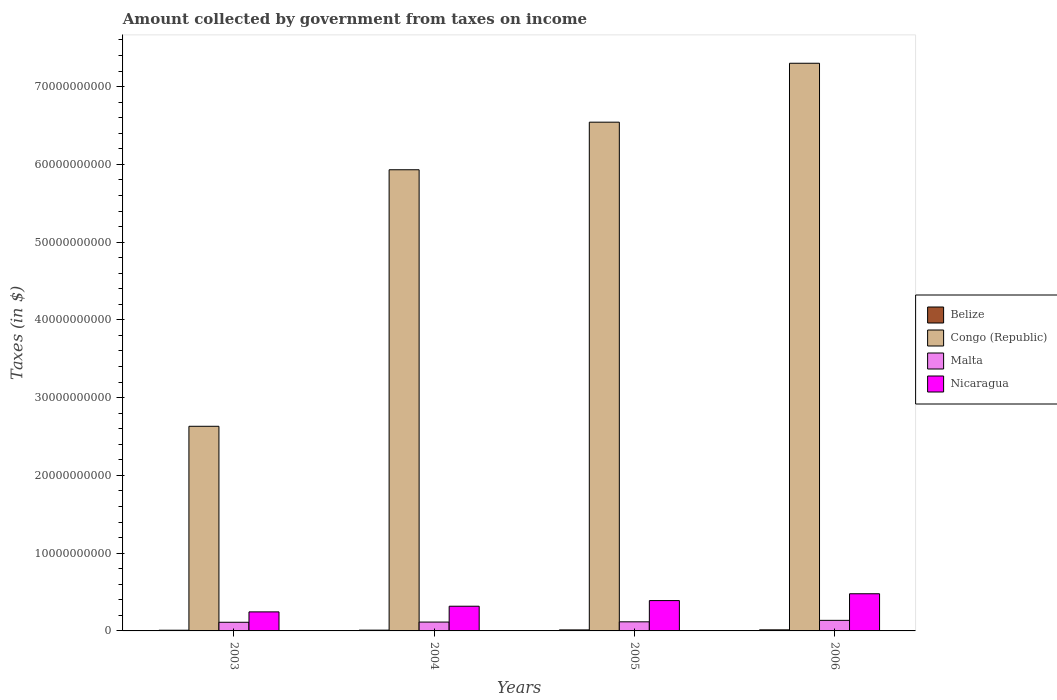Are the number of bars per tick equal to the number of legend labels?
Keep it short and to the point. Yes. Are the number of bars on each tick of the X-axis equal?
Keep it short and to the point. Yes. How many bars are there on the 3rd tick from the left?
Your response must be concise. 4. How many bars are there on the 4th tick from the right?
Your answer should be compact. 4. What is the label of the 1st group of bars from the left?
Provide a succinct answer. 2003. In how many cases, is the number of bars for a given year not equal to the number of legend labels?
Provide a short and direct response. 0. What is the amount collected by government from taxes on income in Nicaragua in 2004?
Ensure brevity in your answer.  3.18e+09. Across all years, what is the maximum amount collected by government from taxes on income in Congo (Republic)?
Provide a short and direct response. 7.30e+1. Across all years, what is the minimum amount collected by government from taxes on income in Malta?
Keep it short and to the point. 1.11e+09. In which year was the amount collected by government from taxes on income in Nicaragua minimum?
Give a very brief answer. 2003. What is the total amount collected by government from taxes on income in Congo (Republic) in the graph?
Offer a terse response. 2.24e+11. What is the difference between the amount collected by government from taxes on income in Nicaragua in 2003 and that in 2004?
Keep it short and to the point. -7.28e+08. What is the difference between the amount collected by government from taxes on income in Belize in 2003 and the amount collected by government from taxes on income in Malta in 2006?
Ensure brevity in your answer.  -1.27e+09. What is the average amount collected by government from taxes on income in Belize per year?
Your answer should be very brief. 1.14e+08. In the year 2005, what is the difference between the amount collected by government from taxes on income in Malta and amount collected by government from taxes on income in Nicaragua?
Provide a succinct answer. -2.73e+09. What is the ratio of the amount collected by government from taxes on income in Malta in 2003 to that in 2005?
Your answer should be compact. 0.95. Is the amount collected by government from taxes on income in Congo (Republic) in 2004 less than that in 2005?
Make the answer very short. Yes. What is the difference between the highest and the second highest amount collected by government from taxes on income in Nicaragua?
Keep it short and to the point. 8.78e+08. What is the difference between the highest and the lowest amount collected by government from taxes on income in Nicaragua?
Keep it short and to the point. 2.33e+09. Is the sum of the amount collected by government from taxes on income in Malta in 2005 and 2006 greater than the maximum amount collected by government from taxes on income in Nicaragua across all years?
Make the answer very short. No. What does the 4th bar from the left in 2004 represents?
Your answer should be compact. Nicaragua. What does the 4th bar from the right in 2005 represents?
Offer a terse response. Belize. Is it the case that in every year, the sum of the amount collected by government from taxes on income in Nicaragua and amount collected by government from taxes on income in Congo (Republic) is greater than the amount collected by government from taxes on income in Malta?
Provide a short and direct response. Yes. How many years are there in the graph?
Keep it short and to the point. 4. What is the difference between two consecutive major ticks on the Y-axis?
Your answer should be very brief. 1.00e+1. Where does the legend appear in the graph?
Your answer should be very brief. Center right. How many legend labels are there?
Your answer should be compact. 4. How are the legend labels stacked?
Provide a short and direct response. Vertical. What is the title of the graph?
Provide a succinct answer. Amount collected by government from taxes on income. Does "Saudi Arabia" appear as one of the legend labels in the graph?
Provide a succinct answer. No. What is the label or title of the Y-axis?
Give a very brief answer. Taxes (in $). What is the Taxes (in $) of Belize in 2003?
Your answer should be compact. 8.91e+07. What is the Taxes (in $) in Congo (Republic) in 2003?
Offer a very short reply. 2.63e+1. What is the Taxes (in $) in Malta in 2003?
Provide a short and direct response. 1.11e+09. What is the Taxes (in $) in Nicaragua in 2003?
Offer a terse response. 2.45e+09. What is the Taxes (in $) of Belize in 2004?
Provide a succinct answer. 9.98e+07. What is the Taxes (in $) in Congo (Republic) in 2004?
Provide a short and direct response. 5.93e+1. What is the Taxes (in $) in Malta in 2004?
Your answer should be compact. 1.14e+09. What is the Taxes (in $) of Nicaragua in 2004?
Give a very brief answer. 3.18e+09. What is the Taxes (in $) of Belize in 2005?
Keep it short and to the point. 1.29e+08. What is the Taxes (in $) in Congo (Republic) in 2005?
Ensure brevity in your answer.  6.54e+1. What is the Taxes (in $) of Malta in 2005?
Give a very brief answer. 1.17e+09. What is the Taxes (in $) in Nicaragua in 2005?
Your answer should be compact. 3.90e+09. What is the Taxes (in $) in Belize in 2006?
Provide a succinct answer. 1.38e+08. What is the Taxes (in $) in Congo (Republic) in 2006?
Provide a succinct answer. 7.30e+1. What is the Taxes (in $) in Malta in 2006?
Make the answer very short. 1.36e+09. What is the Taxes (in $) in Nicaragua in 2006?
Make the answer very short. 4.78e+09. Across all years, what is the maximum Taxes (in $) of Belize?
Give a very brief answer. 1.38e+08. Across all years, what is the maximum Taxes (in $) in Congo (Republic)?
Offer a terse response. 7.30e+1. Across all years, what is the maximum Taxes (in $) in Malta?
Make the answer very short. 1.36e+09. Across all years, what is the maximum Taxes (in $) in Nicaragua?
Your response must be concise. 4.78e+09. Across all years, what is the minimum Taxes (in $) in Belize?
Your answer should be compact. 8.91e+07. Across all years, what is the minimum Taxes (in $) of Congo (Republic)?
Provide a succinct answer. 2.63e+1. Across all years, what is the minimum Taxes (in $) of Malta?
Your answer should be very brief. 1.11e+09. Across all years, what is the minimum Taxes (in $) of Nicaragua?
Keep it short and to the point. 2.45e+09. What is the total Taxes (in $) of Belize in the graph?
Your answer should be very brief. 4.57e+08. What is the total Taxes (in $) of Congo (Republic) in the graph?
Offer a very short reply. 2.24e+11. What is the total Taxes (in $) in Malta in the graph?
Offer a terse response. 4.78e+09. What is the total Taxes (in $) of Nicaragua in the graph?
Provide a short and direct response. 1.43e+1. What is the difference between the Taxes (in $) in Belize in 2003 and that in 2004?
Ensure brevity in your answer.  -1.07e+07. What is the difference between the Taxes (in $) of Congo (Republic) in 2003 and that in 2004?
Give a very brief answer. -3.30e+1. What is the difference between the Taxes (in $) in Malta in 2003 and that in 2004?
Your answer should be very brief. -2.56e+07. What is the difference between the Taxes (in $) in Nicaragua in 2003 and that in 2004?
Your response must be concise. -7.28e+08. What is the difference between the Taxes (in $) of Belize in 2003 and that in 2005?
Keep it short and to the point. -4.03e+07. What is the difference between the Taxes (in $) of Congo (Republic) in 2003 and that in 2005?
Offer a very short reply. -3.91e+1. What is the difference between the Taxes (in $) in Malta in 2003 and that in 2005?
Ensure brevity in your answer.  -5.76e+07. What is the difference between the Taxes (in $) of Nicaragua in 2003 and that in 2005?
Give a very brief answer. -1.45e+09. What is the difference between the Taxes (in $) in Belize in 2003 and that in 2006?
Your response must be concise. -4.91e+07. What is the difference between the Taxes (in $) of Congo (Republic) in 2003 and that in 2006?
Make the answer very short. -4.67e+1. What is the difference between the Taxes (in $) in Malta in 2003 and that in 2006?
Provide a short and direct response. -2.47e+08. What is the difference between the Taxes (in $) in Nicaragua in 2003 and that in 2006?
Your response must be concise. -2.33e+09. What is the difference between the Taxes (in $) in Belize in 2004 and that in 2005?
Provide a succinct answer. -2.96e+07. What is the difference between the Taxes (in $) of Congo (Republic) in 2004 and that in 2005?
Your response must be concise. -6.12e+09. What is the difference between the Taxes (in $) in Malta in 2004 and that in 2005?
Provide a short and direct response. -3.20e+07. What is the difference between the Taxes (in $) of Nicaragua in 2004 and that in 2005?
Your answer should be very brief. -7.26e+08. What is the difference between the Taxes (in $) of Belize in 2004 and that in 2006?
Your answer should be very brief. -3.84e+07. What is the difference between the Taxes (in $) in Congo (Republic) in 2004 and that in 2006?
Make the answer very short. -1.37e+1. What is the difference between the Taxes (in $) in Malta in 2004 and that in 2006?
Make the answer very short. -2.22e+08. What is the difference between the Taxes (in $) of Nicaragua in 2004 and that in 2006?
Your response must be concise. -1.60e+09. What is the difference between the Taxes (in $) in Belize in 2005 and that in 2006?
Provide a short and direct response. -8.74e+06. What is the difference between the Taxes (in $) in Congo (Republic) in 2005 and that in 2006?
Offer a terse response. -7.58e+09. What is the difference between the Taxes (in $) in Malta in 2005 and that in 2006?
Make the answer very short. -1.90e+08. What is the difference between the Taxes (in $) of Nicaragua in 2005 and that in 2006?
Give a very brief answer. -8.78e+08. What is the difference between the Taxes (in $) in Belize in 2003 and the Taxes (in $) in Congo (Republic) in 2004?
Ensure brevity in your answer.  -5.92e+1. What is the difference between the Taxes (in $) of Belize in 2003 and the Taxes (in $) of Malta in 2004?
Your answer should be compact. -1.05e+09. What is the difference between the Taxes (in $) of Belize in 2003 and the Taxes (in $) of Nicaragua in 2004?
Your response must be concise. -3.09e+09. What is the difference between the Taxes (in $) of Congo (Republic) in 2003 and the Taxes (in $) of Malta in 2004?
Offer a very short reply. 2.52e+1. What is the difference between the Taxes (in $) of Congo (Republic) in 2003 and the Taxes (in $) of Nicaragua in 2004?
Provide a succinct answer. 2.31e+1. What is the difference between the Taxes (in $) of Malta in 2003 and the Taxes (in $) of Nicaragua in 2004?
Your answer should be compact. -2.06e+09. What is the difference between the Taxes (in $) of Belize in 2003 and the Taxes (in $) of Congo (Republic) in 2005?
Provide a succinct answer. -6.53e+1. What is the difference between the Taxes (in $) of Belize in 2003 and the Taxes (in $) of Malta in 2005?
Offer a very short reply. -1.08e+09. What is the difference between the Taxes (in $) of Belize in 2003 and the Taxes (in $) of Nicaragua in 2005?
Your answer should be compact. -3.81e+09. What is the difference between the Taxes (in $) in Congo (Republic) in 2003 and the Taxes (in $) in Malta in 2005?
Offer a very short reply. 2.51e+1. What is the difference between the Taxes (in $) in Congo (Republic) in 2003 and the Taxes (in $) in Nicaragua in 2005?
Offer a very short reply. 2.24e+1. What is the difference between the Taxes (in $) in Malta in 2003 and the Taxes (in $) in Nicaragua in 2005?
Give a very brief answer. -2.79e+09. What is the difference between the Taxes (in $) in Belize in 2003 and the Taxes (in $) in Congo (Republic) in 2006?
Your answer should be compact. -7.29e+1. What is the difference between the Taxes (in $) in Belize in 2003 and the Taxes (in $) in Malta in 2006?
Keep it short and to the point. -1.27e+09. What is the difference between the Taxes (in $) in Belize in 2003 and the Taxes (in $) in Nicaragua in 2006?
Ensure brevity in your answer.  -4.69e+09. What is the difference between the Taxes (in $) of Congo (Republic) in 2003 and the Taxes (in $) of Malta in 2006?
Ensure brevity in your answer.  2.50e+1. What is the difference between the Taxes (in $) of Congo (Republic) in 2003 and the Taxes (in $) of Nicaragua in 2006?
Make the answer very short. 2.15e+1. What is the difference between the Taxes (in $) in Malta in 2003 and the Taxes (in $) in Nicaragua in 2006?
Make the answer very short. -3.67e+09. What is the difference between the Taxes (in $) in Belize in 2004 and the Taxes (in $) in Congo (Republic) in 2005?
Offer a very short reply. -6.53e+1. What is the difference between the Taxes (in $) of Belize in 2004 and the Taxes (in $) of Malta in 2005?
Offer a very short reply. -1.07e+09. What is the difference between the Taxes (in $) of Belize in 2004 and the Taxes (in $) of Nicaragua in 2005?
Give a very brief answer. -3.80e+09. What is the difference between the Taxes (in $) of Congo (Republic) in 2004 and the Taxes (in $) of Malta in 2005?
Provide a succinct answer. 5.81e+1. What is the difference between the Taxes (in $) in Congo (Republic) in 2004 and the Taxes (in $) in Nicaragua in 2005?
Keep it short and to the point. 5.54e+1. What is the difference between the Taxes (in $) of Malta in 2004 and the Taxes (in $) of Nicaragua in 2005?
Make the answer very short. -2.76e+09. What is the difference between the Taxes (in $) of Belize in 2004 and the Taxes (in $) of Congo (Republic) in 2006?
Your answer should be compact. -7.29e+1. What is the difference between the Taxes (in $) in Belize in 2004 and the Taxes (in $) in Malta in 2006?
Make the answer very short. -1.26e+09. What is the difference between the Taxes (in $) in Belize in 2004 and the Taxes (in $) in Nicaragua in 2006?
Ensure brevity in your answer.  -4.68e+09. What is the difference between the Taxes (in $) in Congo (Republic) in 2004 and the Taxes (in $) in Malta in 2006?
Make the answer very short. 5.79e+1. What is the difference between the Taxes (in $) in Congo (Republic) in 2004 and the Taxes (in $) in Nicaragua in 2006?
Provide a succinct answer. 5.45e+1. What is the difference between the Taxes (in $) in Malta in 2004 and the Taxes (in $) in Nicaragua in 2006?
Your answer should be compact. -3.64e+09. What is the difference between the Taxes (in $) of Belize in 2005 and the Taxes (in $) of Congo (Republic) in 2006?
Ensure brevity in your answer.  -7.29e+1. What is the difference between the Taxes (in $) in Belize in 2005 and the Taxes (in $) in Malta in 2006?
Ensure brevity in your answer.  -1.23e+09. What is the difference between the Taxes (in $) of Belize in 2005 and the Taxes (in $) of Nicaragua in 2006?
Offer a very short reply. -4.65e+09. What is the difference between the Taxes (in $) in Congo (Republic) in 2005 and the Taxes (in $) in Malta in 2006?
Ensure brevity in your answer.  6.41e+1. What is the difference between the Taxes (in $) of Congo (Republic) in 2005 and the Taxes (in $) of Nicaragua in 2006?
Ensure brevity in your answer.  6.06e+1. What is the difference between the Taxes (in $) of Malta in 2005 and the Taxes (in $) of Nicaragua in 2006?
Provide a succinct answer. -3.61e+09. What is the average Taxes (in $) in Belize per year?
Provide a short and direct response. 1.14e+08. What is the average Taxes (in $) in Congo (Republic) per year?
Your answer should be compact. 5.60e+1. What is the average Taxes (in $) of Malta per year?
Provide a short and direct response. 1.20e+09. What is the average Taxes (in $) in Nicaragua per year?
Your answer should be compact. 3.58e+09. In the year 2003, what is the difference between the Taxes (in $) of Belize and Taxes (in $) of Congo (Republic)?
Make the answer very short. -2.62e+1. In the year 2003, what is the difference between the Taxes (in $) of Belize and Taxes (in $) of Malta?
Your answer should be very brief. -1.02e+09. In the year 2003, what is the difference between the Taxes (in $) in Belize and Taxes (in $) in Nicaragua?
Your answer should be very brief. -2.36e+09. In the year 2003, what is the difference between the Taxes (in $) of Congo (Republic) and Taxes (in $) of Malta?
Your answer should be very brief. 2.52e+1. In the year 2003, what is the difference between the Taxes (in $) of Congo (Republic) and Taxes (in $) of Nicaragua?
Make the answer very short. 2.39e+1. In the year 2003, what is the difference between the Taxes (in $) of Malta and Taxes (in $) of Nicaragua?
Your response must be concise. -1.34e+09. In the year 2004, what is the difference between the Taxes (in $) in Belize and Taxes (in $) in Congo (Republic)?
Ensure brevity in your answer.  -5.92e+1. In the year 2004, what is the difference between the Taxes (in $) in Belize and Taxes (in $) in Malta?
Keep it short and to the point. -1.04e+09. In the year 2004, what is the difference between the Taxes (in $) of Belize and Taxes (in $) of Nicaragua?
Offer a terse response. -3.08e+09. In the year 2004, what is the difference between the Taxes (in $) in Congo (Republic) and Taxes (in $) in Malta?
Offer a very short reply. 5.82e+1. In the year 2004, what is the difference between the Taxes (in $) in Congo (Republic) and Taxes (in $) in Nicaragua?
Provide a succinct answer. 5.61e+1. In the year 2004, what is the difference between the Taxes (in $) in Malta and Taxes (in $) in Nicaragua?
Your answer should be compact. -2.04e+09. In the year 2005, what is the difference between the Taxes (in $) in Belize and Taxes (in $) in Congo (Republic)?
Provide a short and direct response. -6.53e+1. In the year 2005, what is the difference between the Taxes (in $) of Belize and Taxes (in $) of Malta?
Ensure brevity in your answer.  -1.04e+09. In the year 2005, what is the difference between the Taxes (in $) in Belize and Taxes (in $) in Nicaragua?
Offer a terse response. -3.77e+09. In the year 2005, what is the difference between the Taxes (in $) of Congo (Republic) and Taxes (in $) of Malta?
Your answer should be compact. 6.43e+1. In the year 2005, what is the difference between the Taxes (in $) in Congo (Republic) and Taxes (in $) in Nicaragua?
Offer a very short reply. 6.15e+1. In the year 2005, what is the difference between the Taxes (in $) in Malta and Taxes (in $) in Nicaragua?
Your response must be concise. -2.73e+09. In the year 2006, what is the difference between the Taxes (in $) of Belize and Taxes (in $) of Congo (Republic)?
Ensure brevity in your answer.  -7.29e+1. In the year 2006, what is the difference between the Taxes (in $) in Belize and Taxes (in $) in Malta?
Your response must be concise. -1.22e+09. In the year 2006, what is the difference between the Taxes (in $) in Belize and Taxes (in $) in Nicaragua?
Provide a succinct answer. -4.64e+09. In the year 2006, what is the difference between the Taxes (in $) in Congo (Republic) and Taxes (in $) in Malta?
Your answer should be compact. 7.16e+1. In the year 2006, what is the difference between the Taxes (in $) of Congo (Republic) and Taxes (in $) of Nicaragua?
Your answer should be very brief. 6.82e+1. In the year 2006, what is the difference between the Taxes (in $) in Malta and Taxes (in $) in Nicaragua?
Keep it short and to the point. -3.42e+09. What is the ratio of the Taxes (in $) of Belize in 2003 to that in 2004?
Your answer should be compact. 0.89. What is the ratio of the Taxes (in $) of Congo (Republic) in 2003 to that in 2004?
Make the answer very short. 0.44. What is the ratio of the Taxes (in $) in Malta in 2003 to that in 2004?
Provide a succinct answer. 0.98. What is the ratio of the Taxes (in $) in Nicaragua in 2003 to that in 2004?
Offer a terse response. 0.77. What is the ratio of the Taxes (in $) of Belize in 2003 to that in 2005?
Your answer should be very brief. 0.69. What is the ratio of the Taxes (in $) of Congo (Republic) in 2003 to that in 2005?
Your answer should be compact. 0.4. What is the ratio of the Taxes (in $) in Malta in 2003 to that in 2005?
Provide a short and direct response. 0.95. What is the ratio of the Taxes (in $) in Nicaragua in 2003 to that in 2005?
Your answer should be very brief. 0.63. What is the ratio of the Taxes (in $) in Belize in 2003 to that in 2006?
Offer a terse response. 0.64. What is the ratio of the Taxes (in $) in Congo (Republic) in 2003 to that in 2006?
Your answer should be very brief. 0.36. What is the ratio of the Taxes (in $) in Malta in 2003 to that in 2006?
Your answer should be very brief. 0.82. What is the ratio of the Taxes (in $) of Nicaragua in 2003 to that in 2006?
Ensure brevity in your answer.  0.51. What is the ratio of the Taxes (in $) in Belize in 2004 to that in 2005?
Your answer should be compact. 0.77. What is the ratio of the Taxes (in $) in Congo (Republic) in 2004 to that in 2005?
Provide a succinct answer. 0.91. What is the ratio of the Taxes (in $) of Malta in 2004 to that in 2005?
Offer a terse response. 0.97. What is the ratio of the Taxes (in $) of Nicaragua in 2004 to that in 2005?
Keep it short and to the point. 0.81. What is the ratio of the Taxes (in $) in Belize in 2004 to that in 2006?
Offer a terse response. 0.72. What is the ratio of the Taxes (in $) in Congo (Republic) in 2004 to that in 2006?
Your answer should be very brief. 0.81. What is the ratio of the Taxes (in $) in Malta in 2004 to that in 2006?
Offer a terse response. 0.84. What is the ratio of the Taxes (in $) in Nicaragua in 2004 to that in 2006?
Your answer should be very brief. 0.66. What is the ratio of the Taxes (in $) in Belize in 2005 to that in 2006?
Keep it short and to the point. 0.94. What is the ratio of the Taxes (in $) of Congo (Republic) in 2005 to that in 2006?
Keep it short and to the point. 0.9. What is the ratio of the Taxes (in $) in Malta in 2005 to that in 2006?
Your response must be concise. 0.86. What is the ratio of the Taxes (in $) in Nicaragua in 2005 to that in 2006?
Your response must be concise. 0.82. What is the difference between the highest and the second highest Taxes (in $) of Belize?
Offer a terse response. 8.74e+06. What is the difference between the highest and the second highest Taxes (in $) in Congo (Republic)?
Provide a succinct answer. 7.58e+09. What is the difference between the highest and the second highest Taxes (in $) of Malta?
Make the answer very short. 1.90e+08. What is the difference between the highest and the second highest Taxes (in $) of Nicaragua?
Offer a terse response. 8.78e+08. What is the difference between the highest and the lowest Taxes (in $) of Belize?
Provide a succinct answer. 4.91e+07. What is the difference between the highest and the lowest Taxes (in $) in Congo (Republic)?
Provide a succinct answer. 4.67e+1. What is the difference between the highest and the lowest Taxes (in $) in Malta?
Make the answer very short. 2.47e+08. What is the difference between the highest and the lowest Taxes (in $) in Nicaragua?
Offer a terse response. 2.33e+09. 